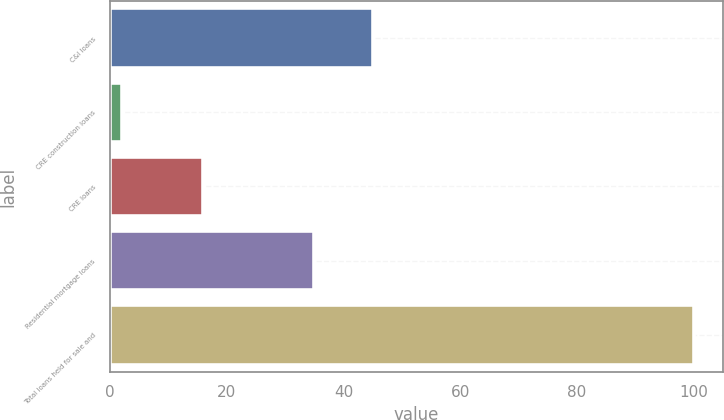<chart> <loc_0><loc_0><loc_500><loc_500><bar_chart><fcel>C&I loans<fcel>CRE construction loans<fcel>CRE loans<fcel>Residential mortgage loans<fcel>Total loans held for sale and<nl><fcel>45<fcel>2<fcel>16<fcel>35<fcel>100<nl></chart> 